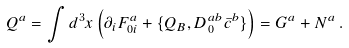<formula> <loc_0><loc_0><loc_500><loc_500>Q ^ { a } = \int d ^ { 3 } x \left ( \partial _ { i } F _ { 0 i } ^ { a } + \{ Q _ { B } , D _ { 0 } ^ { a b } \bar { c } ^ { b } \} \right ) = G ^ { a } + N ^ { a } \, .</formula> 